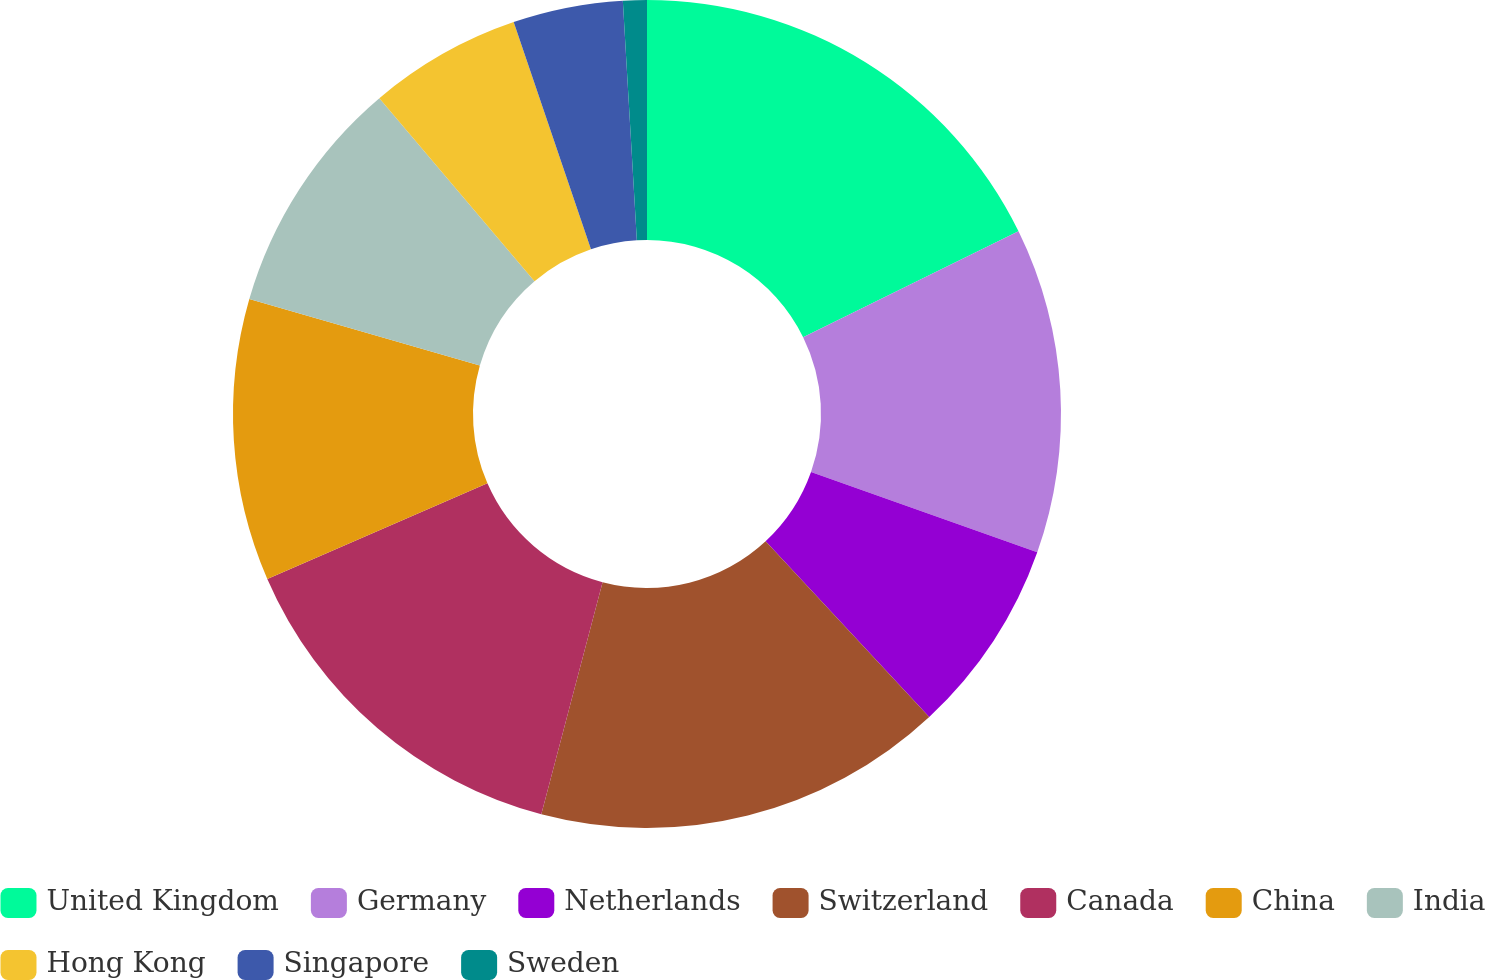<chart> <loc_0><loc_0><loc_500><loc_500><pie_chart><fcel>United Kingdom<fcel>Germany<fcel>Netherlands<fcel>Switzerland<fcel>Canada<fcel>China<fcel>India<fcel>Hong Kong<fcel>Singapore<fcel>Sweden<nl><fcel>17.73%<fcel>12.69%<fcel>7.65%<fcel>16.05%<fcel>14.37%<fcel>11.01%<fcel>9.33%<fcel>5.97%<fcel>4.29%<fcel>0.93%<nl></chart> 